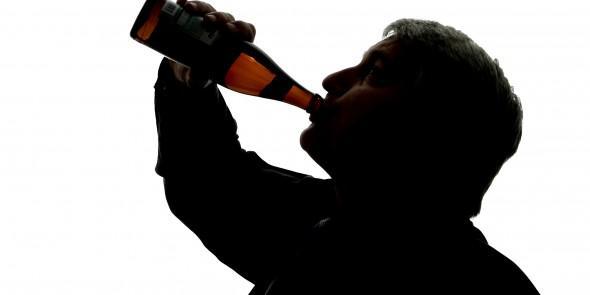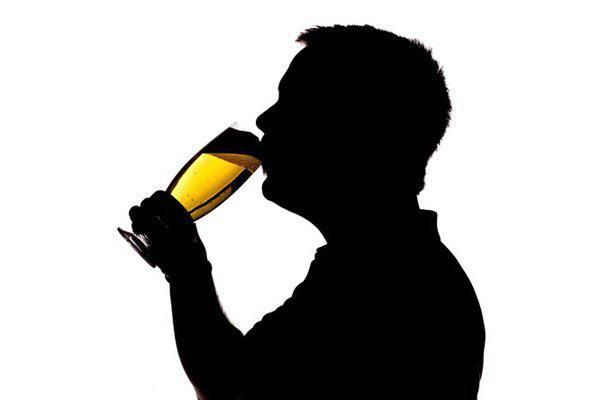The first image is the image on the left, the second image is the image on the right. Examine the images to the left and right. Is the description "In at least one image there is a single male silhouette drink a glass of beer." accurate? Answer yes or no. Yes. The first image is the image on the left, the second image is the image on the right. Evaluate the accuracy of this statement regarding the images: "Two men are drinking and holding their beverage towards the left side of the image.". Is it true? Answer yes or no. Yes. 